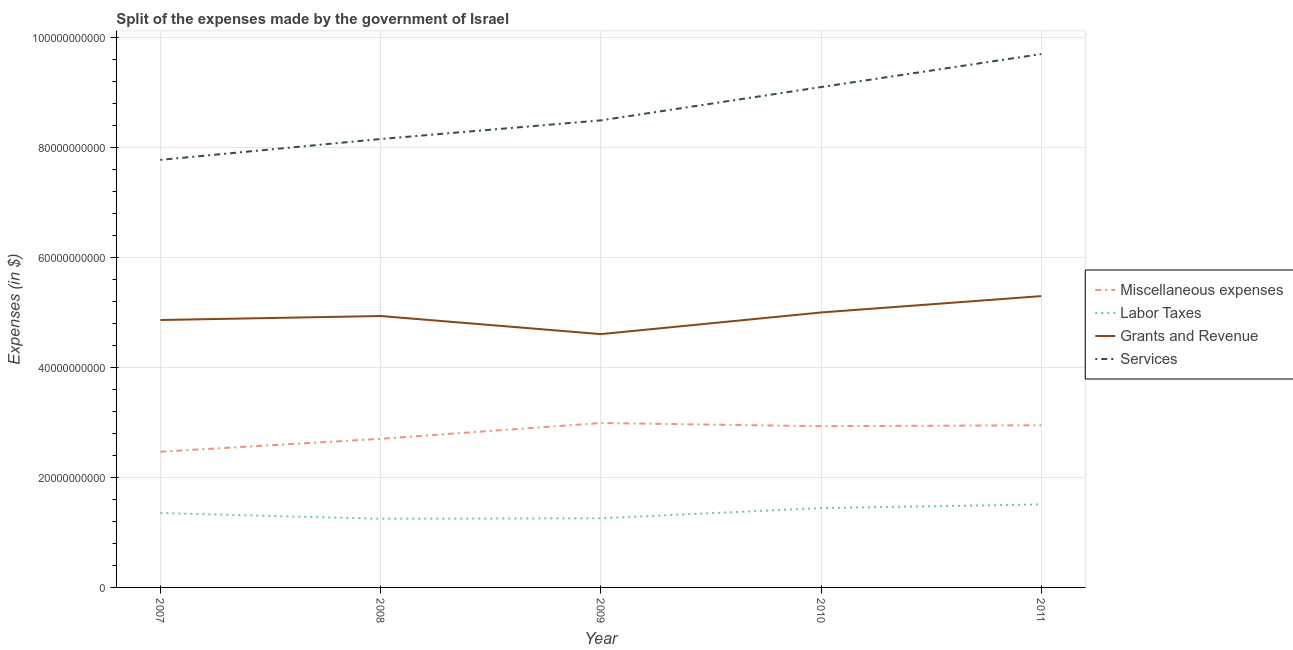How many different coloured lines are there?
Your answer should be compact. 4. Does the line corresponding to amount spent on grants and revenue intersect with the line corresponding to amount spent on services?
Make the answer very short. No. What is the amount spent on labor taxes in 2007?
Your answer should be very brief. 1.35e+1. Across all years, what is the maximum amount spent on services?
Your response must be concise. 9.70e+1. Across all years, what is the minimum amount spent on grants and revenue?
Your response must be concise. 4.61e+1. What is the total amount spent on grants and revenue in the graph?
Your response must be concise. 2.47e+11. What is the difference between the amount spent on miscellaneous expenses in 2007 and that in 2010?
Give a very brief answer. -4.64e+09. What is the difference between the amount spent on services in 2009 and the amount spent on labor taxes in 2007?
Your answer should be very brief. 7.14e+1. What is the average amount spent on miscellaneous expenses per year?
Offer a terse response. 2.81e+1. In the year 2009, what is the difference between the amount spent on services and amount spent on miscellaneous expenses?
Give a very brief answer. 5.50e+1. In how many years, is the amount spent on services greater than 88000000000 $?
Ensure brevity in your answer.  2. What is the ratio of the amount spent on miscellaneous expenses in 2008 to that in 2011?
Make the answer very short. 0.92. Is the difference between the amount spent on services in 2009 and 2010 greater than the difference between the amount spent on grants and revenue in 2009 and 2010?
Offer a terse response. No. What is the difference between the highest and the second highest amount spent on services?
Provide a short and direct response. 6.00e+09. What is the difference between the highest and the lowest amount spent on labor taxes?
Your response must be concise. 2.60e+09. In how many years, is the amount spent on grants and revenue greater than the average amount spent on grants and revenue taken over all years?
Provide a succinct answer. 2. Is the sum of the amount spent on services in 2008 and 2011 greater than the maximum amount spent on grants and revenue across all years?
Provide a succinct answer. Yes. Is it the case that in every year, the sum of the amount spent on miscellaneous expenses and amount spent on labor taxes is greater than the amount spent on grants and revenue?
Your answer should be compact. No. Does the amount spent on grants and revenue monotonically increase over the years?
Give a very brief answer. No. Is the amount spent on miscellaneous expenses strictly greater than the amount spent on services over the years?
Ensure brevity in your answer.  No. How many lines are there?
Provide a short and direct response. 4. Are the values on the major ticks of Y-axis written in scientific E-notation?
Provide a short and direct response. No. Does the graph contain any zero values?
Keep it short and to the point. No. Does the graph contain grids?
Your answer should be very brief. Yes. How many legend labels are there?
Offer a very short reply. 4. How are the legend labels stacked?
Your answer should be compact. Vertical. What is the title of the graph?
Ensure brevity in your answer.  Split of the expenses made by the government of Israel. Does "Korea" appear as one of the legend labels in the graph?
Give a very brief answer. No. What is the label or title of the X-axis?
Provide a succinct answer. Year. What is the label or title of the Y-axis?
Offer a terse response. Expenses (in $). What is the Expenses (in $) in Miscellaneous expenses in 2007?
Your answer should be very brief. 2.47e+1. What is the Expenses (in $) of Labor Taxes in 2007?
Provide a short and direct response. 1.35e+1. What is the Expenses (in $) in Grants and Revenue in 2007?
Your answer should be compact. 4.86e+1. What is the Expenses (in $) in Services in 2007?
Provide a short and direct response. 7.77e+1. What is the Expenses (in $) of Miscellaneous expenses in 2008?
Your response must be concise. 2.70e+1. What is the Expenses (in $) of Labor Taxes in 2008?
Ensure brevity in your answer.  1.25e+1. What is the Expenses (in $) in Grants and Revenue in 2008?
Your response must be concise. 4.93e+1. What is the Expenses (in $) in Services in 2008?
Your answer should be compact. 8.15e+1. What is the Expenses (in $) in Miscellaneous expenses in 2009?
Your answer should be very brief. 2.99e+1. What is the Expenses (in $) of Labor Taxes in 2009?
Make the answer very short. 1.26e+1. What is the Expenses (in $) of Grants and Revenue in 2009?
Your answer should be very brief. 4.61e+1. What is the Expenses (in $) of Services in 2009?
Your response must be concise. 8.49e+1. What is the Expenses (in $) of Miscellaneous expenses in 2010?
Provide a short and direct response. 2.93e+1. What is the Expenses (in $) in Labor Taxes in 2010?
Keep it short and to the point. 1.44e+1. What is the Expenses (in $) in Grants and Revenue in 2010?
Offer a very short reply. 5.00e+1. What is the Expenses (in $) of Services in 2010?
Your answer should be very brief. 9.10e+1. What is the Expenses (in $) in Miscellaneous expenses in 2011?
Offer a terse response. 2.95e+1. What is the Expenses (in $) of Labor Taxes in 2011?
Provide a short and direct response. 1.51e+1. What is the Expenses (in $) of Grants and Revenue in 2011?
Provide a short and direct response. 5.30e+1. What is the Expenses (in $) of Services in 2011?
Provide a succinct answer. 9.70e+1. Across all years, what is the maximum Expenses (in $) in Miscellaneous expenses?
Offer a very short reply. 2.99e+1. Across all years, what is the maximum Expenses (in $) of Labor Taxes?
Provide a short and direct response. 1.51e+1. Across all years, what is the maximum Expenses (in $) of Grants and Revenue?
Offer a very short reply. 5.30e+1. Across all years, what is the maximum Expenses (in $) in Services?
Your response must be concise. 9.70e+1. Across all years, what is the minimum Expenses (in $) in Miscellaneous expenses?
Provide a succinct answer. 2.47e+1. Across all years, what is the minimum Expenses (in $) of Labor Taxes?
Provide a succinct answer. 1.25e+1. Across all years, what is the minimum Expenses (in $) in Grants and Revenue?
Ensure brevity in your answer.  4.61e+1. Across all years, what is the minimum Expenses (in $) of Services?
Keep it short and to the point. 7.77e+1. What is the total Expenses (in $) in Miscellaneous expenses in the graph?
Your answer should be very brief. 1.40e+11. What is the total Expenses (in $) of Labor Taxes in the graph?
Provide a short and direct response. 6.81e+1. What is the total Expenses (in $) of Grants and Revenue in the graph?
Ensure brevity in your answer.  2.47e+11. What is the total Expenses (in $) in Services in the graph?
Offer a very short reply. 4.32e+11. What is the difference between the Expenses (in $) of Miscellaneous expenses in 2007 and that in 2008?
Give a very brief answer. -2.35e+09. What is the difference between the Expenses (in $) of Labor Taxes in 2007 and that in 2008?
Make the answer very short. 1.04e+09. What is the difference between the Expenses (in $) in Grants and Revenue in 2007 and that in 2008?
Offer a terse response. -7.26e+08. What is the difference between the Expenses (in $) in Services in 2007 and that in 2008?
Your answer should be compact. -3.79e+09. What is the difference between the Expenses (in $) in Miscellaneous expenses in 2007 and that in 2009?
Offer a very short reply. -5.22e+09. What is the difference between the Expenses (in $) in Labor Taxes in 2007 and that in 2009?
Provide a short and direct response. 9.55e+08. What is the difference between the Expenses (in $) of Grants and Revenue in 2007 and that in 2009?
Ensure brevity in your answer.  2.57e+09. What is the difference between the Expenses (in $) of Services in 2007 and that in 2009?
Provide a short and direct response. -7.18e+09. What is the difference between the Expenses (in $) in Miscellaneous expenses in 2007 and that in 2010?
Keep it short and to the point. -4.64e+09. What is the difference between the Expenses (in $) of Labor Taxes in 2007 and that in 2010?
Make the answer very short. -9.02e+08. What is the difference between the Expenses (in $) of Grants and Revenue in 2007 and that in 2010?
Your response must be concise. -1.37e+09. What is the difference between the Expenses (in $) of Services in 2007 and that in 2010?
Your response must be concise. -1.32e+1. What is the difference between the Expenses (in $) of Miscellaneous expenses in 2007 and that in 2011?
Offer a terse response. -4.81e+09. What is the difference between the Expenses (in $) in Labor Taxes in 2007 and that in 2011?
Give a very brief answer. -1.56e+09. What is the difference between the Expenses (in $) in Grants and Revenue in 2007 and that in 2011?
Keep it short and to the point. -4.34e+09. What is the difference between the Expenses (in $) in Services in 2007 and that in 2011?
Your answer should be very brief. -1.92e+1. What is the difference between the Expenses (in $) in Miscellaneous expenses in 2008 and that in 2009?
Make the answer very short. -2.87e+09. What is the difference between the Expenses (in $) in Labor Taxes in 2008 and that in 2009?
Offer a terse response. -9.00e+07. What is the difference between the Expenses (in $) of Grants and Revenue in 2008 and that in 2009?
Give a very brief answer. 3.29e+09. What is the difference between the Expenses (in $) of Services in 2008 and that in 2009?
Your answer should be compact. -3.39e+09. What is the difference between the Expenses (in $) of Miscellaneous expenses in 2008 and that in 2010?
Offer a terse response. -2.29e+09. What is the difference between the Expenses (in $) in Labor Taxes in 2008 and that in 2010?
Provide a succinct answer. -1.95e+09. What is the difference between the Expenses (in $) of Grants and Revenue in 2008 and that in 2010?
Your response must be concise. -6.44e+08. What is the difference between the Expenses (in $) of Services in 2008 and that in 2010?
Offer a very short reply. -9.45e+09. What is the difference between the Expenses (in $) of Miscellaneous expenses in 2008 and that in 2011?
Offer a terse response. -2.46e+09. What is the difference between the Expenses (in $) of Labor Taxes in 2008 and that in 2011?
Provide a short and direct response. -2.60e+09. What is the difference between the Expenses (in $) of Grants and Revenue in 2008 and that in 2011?
Ensure brevity in your answer.  -3.62e+09. What is the difference between the Expenses (in $) in Services in 2008 and that in 2011?
Provide a succinct answer. -1.54e+1. What is the difference between the Expenses (in $) of Miscellaneous expenses in 2009 and that in 2010?
Your answer should be very brief. 5.78e+08. What is the difference between the Expenses (in $) in Labor Taxes in 2009 and that in 2010?
Ensure brevity in your answer.  -1.86e+09. What is the difference between the Expenses (in $) of Grants and Revenue in 2009 and that in 2010?
Provide a short and direct response. -3.93e+09. What is the difference between the Expenses (in $) of Services in 2009 and that in 2010?
Ensure brevity in your answer.  -6.05e+09. What is the difference between the Expenses (in $) of Miscellaneous expenses in 2009 and that in 2011?
Ensure brevity in your answer.  4.09e+08. What is the difference between the Expenses (in $) of Labor Taxes in 2009 and that in 2011?
Give a very brief answer. -2.51e+09. What is the difference between the Expenses (in $) of Grants and Revenue in 2009 and that in 2011?
Offer a very short reply. -6.91e+09. What is the difference between the Expenses (in $) of Services in 2009 and that in 2011?
Provide a short and direct response. -1.21e+1. What is the difference between the Expenses (in $) in Miscellaneous expenses in 2010 and that in 2011?
Keep it short and to the point. -1.70e+08. What is the difference between the Expenses (in $) of Labor Taxes in 2010 and that in 2011?
Your response must be concise. -6.57e+08. What is the difference between the Expenses (in $) in Grants and Revenue in 2010 and that in 2011?
Give a very brief answer. -2.97e+09. What is the difference between the Expenses (in $) of Services in 2010 and that in 2011?
Provide a succinct answer. -6.00e+09. What is the difference between the Expenses (in $) of Miscellaneous expenses in 2007 and the Expenses (in $) of Labor Taxes in 2008?
Ensure brevity in your answer.  1.22e+1. What is the difference between the Expenses (in $) in Miscellaneous expenses in 2007 and the Expenses (in $) in Grants and Revenue in 2008?
Your answer should be very brief. -2.47e+1. What is the difference between the Expenses (in $) in Miscellaneous expenses in 2007 and the Expenses (in $) in Services in 2008?
Your answer should be compact. -5.68e+1. What is the difference between the Expenses (in $) of Labor Taxes in 2007 and the Expenses (in $) of Grants and Revenue in 2008?
Your answer should be very brief. -3.58e+1. What is the difference between the Expenses (in $) in Labor Taxes in 2007 and the Expenses (in $) in Services in 2008?
Offer a very short reply. -6.80e+1. What is the difference between the Expenses (in $) in Grants and Revenue in 2007 and the Expenses (in $) in Services in 2008?
Offer a terse response. -3.29e+1. What is the difference between the Expenses (in $) in Miscellaneous expenses in 2007 and the Expenses (in $) in Labor Taxes in 2009?
Provide a succinct answer. 1.21e+1. What is the difference between the Expenses (in $) in Miscellaneous expenses in 2007 and the Expenses (in $) in Grants and Revenue in 2009?
Ensure brevity in your answer.  -2.14e+1. What is the difference between the Expenses (in $) of Miscellaneous expenses in 2007 and the Expenses (in $) of Services in 2009?
Your answer should be very brief. -6.02e+1. What is the difference between the Expenses (in $) in Labor Taxes in 2007 and the Expenses (in $) in Grants and Revenue in 2009?
Provide a short and direct response. -3.25e+1. What is the difference between the Expenses (in $) of Labor Taxes in 2007 and the Expenses (in $) of Services in 2009?
Give a very brief answer. -7.14e+1. What is the difference between the Expenses (in $) in Grants and Revenue in 2007 and the Expenses (in $) in Services in 2009?
Give a very brief answer. -3.63e+1. What is the difference between the Expenses (in $) of Miscellaneous expenses in 2007 and the Expenses (in $) of Labor Taxes in 2010?
Keep it short and to the point. 1.02e+1. What is the difference between the Expenses (in $) of Miscellaneous expenses in 2007 and the Expenses (in $) of Grants and Revenue in 2010?
Make the answer very short. -2.53e+1. What is the difference between the Expenses (in $) in Miscellaneous expenses in 2007 and the Expenses (in $) in Services in 2010?
Provide a short and direct response. -6.63e+1. What is the difference between the Expenses (in $) of Labor Taxes in 2007 and the Expenses (in $) of Grants and Revenue in 2010?
Your answer should be very brief. -3.65e+1. What is the difference between the Expenses (in $) of Labor Taxes in 2007 and the Expenses (in $) of Services in 2010?
Make the answer very short. -7.74e+1. What is the difference between the Expenses (in $) of Grants and Revenue in 2007 and the Expenses (in $) of Services in 2010?
Provide a short and direct response. -4.24e+1. What is the difference between the Expenses (in $) of Miscellaneous expenses in 2007 and the Expenses (in $) of Labor Taxes in 2011?
Your response must be concise. 9.59e+09. What is the difference between the Expenses (in $) of Miscellaneous expenses in 2007 and the Expenses (in $) of Grants and Revenue in 2011?
Your answer should be compact. -2.83e+1. What is the difference between the Expenses (in $) of Miscellaneous expenses in 2007 and the Expenses (in $) of Services in 2011?
Offer a very short reply. -7.23e+1. What is the difference between the Expenses (in $) in Labor Taxes in 2007 and the Expenses (in $) in Grants and Revenue in 2011?
Give a very brief answer. -3.94e+1. What is the difference between the Expenses (in $) of Labor Taxes in 2007 and the Expenses (in $) of Services in 2011?
Offer a terse response. -8.34e+1. What is the difference between the Expenses (in $) in Grants and Revenue in 2007 and the Expenses (in $) in Services in 2011?
Keep it short and to the point. -4.83e+1. What is the difference between the Expenses (in $) in Miscellaneous expenses in 2008 and the Expenses (in $) in Labor Taxes in 2009?
Provide a succinct answer. 1.44e+1. What is the difference between the Expenses (in $) of Miscellaneous expenses in 2008 and the Expenses (in $) of Grants and Revenue in 2009?
Make the answer very short. -1.90e+1. What is the difference between the Expenses (in $) in Miscellaneous expenses in 2008 and the Expenses (in $) in Services in 2009?
Offer a very short reply. -5.79e+1. What is the difference between the Expenses (in $) in Labor Taxes in 2008 and the Expenses (in $) in Grants and Revenue in 2009?
Give a very brief answer. -3.36e+1. What is the difference between the Expenses (in $) of Labor Taxes in 2008 and the Expenses (in $) of Services in 2009?
Your answer should be very brief. -7.24e+1. What is the difference between the Expenses (in $) of Grants and Revenue in 2008 and the Expenses (in $) of Services in 2009?
Your answer should be very brief. -3.56e+1. What is the difference between the Expenses (in $) in Miscellaneous expenses in 2008 and the Expenses (in $) in Labor Taxes in 2010?
Your answer should be compact. 1.26e+1. What is the difference between the Expenses (in $) in Miscellaneous expenses in 2008 and the Expenses (in $) in Grants and Revenue in 2010?
Your response must be concise. -2.30e+1. What is the difference between the Expenses (in $) of Miscellaneous expenses in 2008 and the Expenses (in $) of Services in 2010?
Your answer should be very brief. -6.39e+1. What is the difference between the Expenses (in $) in Labor Taxes in 2008 and the Expenses (in $) in Grants and Revenue in 2010?
Your response must be concise. -3.75e+1. What is the difference between the Expenses (in $) of Labor Taxes in 2008 and the Expenses (in $) of Services in 2010?
Your response must be concise. -7.85e+1. What is the difference between the Expenses (in $) of Grants and Revenue in 2008 and the Expenses (in $) of Services in 2010?
Give a very brief answer. -4.16e+1. What is the difference between the Expenses (in $) of Miscellaneous expenses in 2008 and the Expenses (in $) of Labor Taxes in 2011?
Your response must be concise. 1.19e+1. What is the difference between the Expenses (in $) in Miscellaneous expenses in 2008 and the Expenses (in $) in Grants and Revenue in 2011?
Keep it short and to the point. -2.59e+1. What is the difference between the Expenses (in $) in Miscellaneous expenses in 2008 and the Expenses (in $) in Services in 2011?
Offer a terse response. -6.99e+1. What is the difference between the Expenses (in $) of Labor Taxes in 2008 and the Expenses (in $) of Grants and Revenue in 2011?
Offer a terse response. -4.05e+1. What is the difference between the Expenses (in $) of Labor Taxes in 2008 and the Expenses (in $) of Services in 2011?
Ensure brevity in your answer.  -8.45e+1. What is the difference between the Expenses (in $) of Grants and Revenue in 2008 and the Expenses (in $) of Services in 2011?
Provide a short and direct response. -4.76e+1. What is the difference between the Expenses (in $) in Miscellaneous expenses in 2009 and the Expenses (in $) in Labor Taxes in 2010?
Offer a very short reply. 1.55e+1. What is the difference between the Expenses (in $) in Miscellaneous expenses in 2009 and the Expenses (in $) in Grants and Revenue in 2010?
Provide a succinct answer. -2.01e+1. What is the difference between the Expenses (in $) of Miscellaneous expenses in 2009 and the Expenses (in $) of Services in 2010?
Ensure brevity in your answer.  -6.11e+1. What is the difference between the Expenses (in $) of Labor Taxes in 2009 and the Expenses (in $) of Grants and Revenue in 2010?
Provide a succinct answer. -3.74e+1. What is the difference between the Expenses (in $) of Labor Taxes in 2009 and the Expenses (in $) of Services in 2010?
Provide a short and direct response. -7.84e+1. What is the difference between the Expenses (in $) in Grants and Revenue in 2009 and the Expenses (in $) in Services in 2010?
Give a very brief answer. -4.49e+1. What is the difference between the Expenses (in $) of Miscellaneous expenses in 2009 and the Expenses (in $) of Labor Taxes in 2011?
Your answer should be compact. 1.48e+1. What is the difference between the Expenses (in $) in Miscellaneous expenses in 2009 and the Expenses (in $) in Grants and Revenue in 2011?
Keep it short and to the point. -2.31e+1. What is the difference between the Expenses (in $) of Miscellaneous expenses in 2009 and the Expenses (in $) of Services in 2011?
Offer a terse response. -6.71e+1. What is the difference between the Expenses (in $) in Labor Taxes in 2009 and the Expenses (in $) in Grants and Revenue in 2011?
Your answer should be very brief. -4.04e+1. What is the difference between the Expenses (in $) in Labor Taxes in 2009 and the Expenses (in $) in Services in 2011?
Make the answer very short. -8.44e+1. What is the difference between the Expenses (in $) in Grants and Revenue in 2009 and the Expenses (in $) in Services in 2011?
Offer a very short reply. -5.09e+1. What is the difference between the Expenses (in $) in Miscellaneous expenses in 2010 and the Expenses (in $) in Labor Taxes in 2011?
Offer a terse response. 1.42e+1. What is the difference between the Expenses (in $) of Miscellaneous expenses in 2010 and the Expenses (in $) of Grants and Revenue in 2011?
Offer a terse response. -2.36e+1. What is the difference between the Expenses (in $) in Miscellaneous expenses in 2010 and the Expenses (in $) in Services in 2011?
Ensure brevity in your answer.  -6.77e+1. What is the difference between the Expenses (in $) of Labor Taxes in 2010 and the Expenses (in $) of Grants and Revenue in 2011?
Ensure brevity in your answer.  -3.85e+1. What is the difference between the Expenses (in $) of Labor Taxes in 2010 and the Expenses (in $) of Services in 2011?
Your answer should be very brief. -8.25e+1. What is the difference between the Expenses (in $) in Grants and Revenue in 2010 and the Expenses (in $) in Services in 2011?
Give a very brief answer. -4.70e+1. What is the average Expenses (in $) of Miscellaneous expenses per year?
Your answer should be very brief. 2.81e+1. What is the average Expenses (in $) in Labor Taxes per year?
Your answer should be compact. 1.36e+1. What is the average Expenses (in $) in Grants and Revenue per year?
Your answer should be compact. 4.94e+1. What is the average Expenses (in $) in Services per year?
Your answer should be very brief. 8.64e+1. In the year 2007, what is the difference between the Expenses (in $) in Miscellaneous expenses and Expenses (in $) in Labor Taxes?
Offer a terse response. 1.11e+1. In the year 2007, what is the difference between the Expenses (in $) of Miscellaneous expenses and Expenses (in $) of Grants and Revenue?
Your response must be concise. -2.39e+1. In the year 2007, what is the difference between the Expenses (in $) in Miscellaneous expenses and Expenses (in $) in Services?
Your answer should be very brief. -5.31e+1. In the year 2007, what is the difference between the Expenses (in $) of Labor Taxes and Expenses (in $) of Grants and Revenue?
Your response must be concise. -3.51e+1. In the year 2007, what is the difference between the Expenses (in $) of Labor Taxes and Expenses (in $) of Services?
Ensure brevity in your answer.  -6.42e+1. In the year 2007, what is the difference between the Expenses (in $) of Grants and Revenue and Expenses (in $) of Services?
Make the answer very short. -2.91e+1. In the year 2008, what is the difference between the Expenses (in $) of Miscellaneous expenses and Expenses (in $) of Labor Taxes?
Offer a very short reply. 1.45e+1. In the year 2008, what is the difference between the Expenses (in $) in Miscellaneous expenses and Expenses (in $) in Grants and Revenue?
Keep it short and to the point. -2.23e+1. In the year 2008, what is the difference between the Expenses (in $) in Miscellaneous expenses and Expenses (in $) in Services?
Provide a succinct answer. -5.45e+1. In the year 2008, what is the difference between the Expenses (in $) of Labor Taxes and Expenses (in $) of Grants and Revenue?
Ensure brevity in your answer.  -3.69e+1. In the year 2008, what is the difference between the Expenses (in $) in Labor Taxes and Expenses (in $) in Services?
Make the answer very short. -6.90e+1. In the year 2008, what is the difference between the Expenses (in $) of Grants and Revenue and Expenses (in $) of Services?
Your response must be concise. -3.22e+1. In the year 2009, what is the difference between the Expenses (in $) of Miscellaneous expenses and Expenses (in $) of Labor Taxes?
Offer a terse response. 1.73e+1. In the year 2009, what is the difference between the Expenses (in $) of Miscellaneous expenses and Expenses (in $) of Grants and Revenue?
Offer a terse response. -1.62e+1. In the year 2009, what is the difference between the Expenses (in $) in Miscellaneous expenses and Expenses (in $) in Services?
Ensure brevity in your answer.  -5.50e+1. In the year 2009, what is the difference between the Expenses (in $) in Labor Taxes and Expenses (in $) in Grants and Revenue?
Offer a terse response. -3.35e+1. In the year 2009, what is the difference between the Expenses (in $) of Labor Taxes and Expenses (in $) of Services?
Provide a short and direct response. -7.23e+1. In the year 2009, what is the difference between the Expenses (in $) of Grants and Revenue and Expenses (in $) of Services?
Make the answer very short. -3.89e+1. In the year 2010, what is the difference between the Expenses (in $) in Miscellaneous expenses and Expenses (in $) in Labor Taxes?
Offer a very short reply. 1.49e+1. In the year 2010, what is the difference between the Expenses (in $) of Miscellaneous expenses and Expenses (in $) of Grants and Revenue?
Give a very brief answer. -2.07e+1. In the year 2010, what is the difference between the Expenses (in $) in Miscellaneous expenses and Expenses (in $) in Services?
Ensure brevity in your answer.  -6.17e+1. In the year 2010, what is the difference between the Expenses (in $) of Labor Taxes and Expenses (in $) of Grants and Revenue?
Your response must be concise. -3.56e+1. In the year 2010, what is the difference between the Expenses (in $) in Labor Taxes and Expenses (in $) in Services?
Offer a very short reply. -7.65e+1. In the year 2010, what is the difference between the Expenses (in $) in Grants and Revenue and Expenses (in $) in Services?
Make the answer very short. -4.10e+1. In the year 2011, what is the difference between the Expenses (in $) in Miscellaneous expenses and Expenses (in $) in Labor Taxes?
Your response must be concise. 1.44e+1. In the year 2011, what is the difference between the Expenses (in $) in Miscellaneous expenses and Expenses (in $) in Grants and Revenue?
Offer a very short reply. -2.35e+1. In the year 2011, what is the difference between the Expenses (in $) of Miscellaneous expenses and Expenses (in $) of Services?
Your answer should be compact. -6.75e+1. In the year 2011, what is the difference between the Expenses (in $) in Labor Taxes and Expenses (in $) in Grants and Revenue?
Your response must be concise. -3.79e+1. In the year 2011, what is the difference between the Expenses (in $) of Labor Taxes and Expenses (in $) of Services?
Give a very brief answer. -8.19e+1. In the year 2011, what is the difference between the Expenses (in $) of Grants and Revenue and Expenses (in $) of Services?
Your response must be concise. -4.40e+1. What is the ratio of the Expenses (in $) in Miscellaneous expenses in 2007 to that in 2008?
Your answer should be compact. 0.91. What is the ratio of the Expenses (in $) of Labor Taxes in 2007 to that in 2008?
Make the answer very short. 1.08. What is the ratio of the Expenses (in $) of Grants and Revenue in 2007 to that in 2008?
Keep it short and to the point. 0.99. What is the ratio of the Expenses (in $) in Services in 2007 to that in 2008?
Provide a short and direct response. 0.95. What is the ratio of the Expenses (in $) of Miscellaneous expenses in 2007 to that in 2009?
Give a very brief answer. 0.83. What is the ratio of the Expenses (in $) of Labor Taxes in 2007 to that in 2009?
Your answer should be very brief. 1.08. What is the ratio of the Expenses (in $) of Grants and Revenue in 2007 to that in 2009?
Ensure brevity in your answer.  1.06. What is the ratio of the Expenses (in $) of Services in 2007 to that in 2009?
Give a very brief answer. 0.92. What is the ratio of the Expenses (in $) of Miscellaneous expenses in 2007 to that in 2010?
Provide a short and direct response. 0.84. What is the ratio of the Expenses (in $) of Labor Taxes in 2007 to that in 2010?
Keep it short and to the point. 0.94. What is the ratio of the Expenses (in $) in Grants and Revenue in 2007 to that in 2010?
Give a very brief answer. 0.97. What is the ratio of the Expenses (in $) in Services in 2007 to that in 2010?
Your answer should be compact. 0.85. What is the ratio of the Expenses (in $) of Miscellaneous expenses in 2007 to that in 2011?
Your response must be concise. 0.84. What is the ratio of the Expenses (in $) in Labor Taxes in 2007 to that in 2011?
Your response must be concise. 0.9. What is the ratio of the Expenses (in $) in Grants and Revenue in 2007 to that in 2011?
Keep it short and to the point. 0.92. What is the ratio of the Expenses (in $) of Services in 2007 to that in 2011?
Give a very brief answer. 0.8. What is the ratio of the Expenses (in $) in Miscellaneous expenses in 2008 to that in 2009?
Give a very brief answer. 0.9. What is the ratio of the Expenses (in $) of Labor Taxes in 2008 to that in 2009?
Your answer should be very brief. 0.99. What is the ratio of the Expenses (in $) of Grants and Revenue in 2008 to that in 2009?
Your answer should be very brief. 1.07. What is the ratio of the Expenses (in $) in Miscellaneous expenses in 2008 to that in 2010?
Your response must be concise. 0.92. What is the ratio of the Expenses (in $) of Labor Taxes in 2008 to that in 2010?
Your answer should be compact. 0.87. What is the ratio of the Expenses (in $) of Grants and Revenue in 2008 to that in 2010?
Provide a short and direct response. 0.99. What is the ratio of the Expenses (in $) of Services in 2008 to that in 2010?
Give a very brief answer. 0.9. What is the ratio of the Expenses (in $) in Miscellaneous expenses in 2008 to that in 2011?
Ensure brevity in your answer.  0.92. What is the ratio of the Expenses (in $) of Labor Taxes in 2008 to that in 2011?
Keep it short and to the point. 0.83. What is the ratio of the Expenses (in $) in Grants and Revenue in 2008 to that in 2011?
Ensure brevity in your answer.  0.93. What is the ratio of the Expenses (in $) in Services in 2008 to that in 2011?
Your answer should be very brief. 0.84. What is the ratio of the Expenses (in $) of Miscellaneous expenses in 2009 to that in 2010?
Keep it short and to the point. 1.02. What is the ratio of the Expenses (in $) in Labor Taxes in 2009 to that in 2010?
Offer a terse response. 0.87. What is the ratio of the Expenses (in $) of Grants and Revenue in 2009 to that in 2010?
Your answer should be compact. 0.92. What is the ratio of the Expenses (in $) in Services in 2009 to that in 2010?
Your answer should be compact. 0.93. What is the ratio of the Expenses (in $) in Miscellaneous expenses in 2009 to that in 2011?
Provide a succinct answer. 1.01. What is the ratio of the Expenses (in $) of Labor Taxes in 2009 to that in 2011?
Provide a short and direct response. 0.83. What is the ratio of the Expenses (in $) in Grants and Revenue in 2009 to that in 2011?
Your response must be concise. 0.87. What is the ratio of the Expenses (in $) of Services in 2009 to that in 2011?
Give a very brief answer. 0.88. What is the ratio of the Expenses (in $) of Labor Taxes in 2010 to that in 2011?
Make the answer very short. 0.96. What is the ratio of the Expenses (in $) of Grants and Revenue in 2010 to that in 2011?
Your answer should be compact. 0.94. What is the ratio of the Expenses (in $) of Services in 2010 to that in 2011?
Your answer should be very brief. 0.94. What is the difference between the highest and the second highest Expenses (in $) of Miscellaneous expenses?
Provide a succinct answer. 4.09e+08. What is the difference between the highest and the second highest Expenses (in $) of Labor Taxes?
Provide a short and direct response. 6.57e+08. What is the difference between the highest and the second highest Expenses (in $) of Grants and Revenue?
Give a very brief answer. 2.97e+09. What is the difference between the highest and the second highest Expenses (in $) in Services?
Offer a very short reply. 6.00e+09. What is the difference between the highest and the lowest Expenses (in $) in Miscellaneous expenses?
Offer a terse response. 5.22e+09. What is the difference between the highest and the lowest Expenses (in $) of Labor Taxes?
Your response must be concise. 2.60e+09. What is the difference between the highest and the lowest Expenses (in $) of Grants and Revenue?
Ensure brevity in your answer.  6.91e+09. What is the difference between the highest and the lowest Expenses (in $) of Services?
Give a very brief answer. 1.92e+1. 